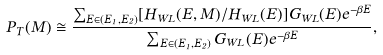<formula> <loc_0><loc_0><loc_500><loc_500>P _ { T } ( M ) \cong \frac { \sum _ { E \in ( E _ { 1 } , E _ { 2 } ) } [ H _ { W L } ( E , M ) / H _ { W L } ( E ) ] G _ { W L } ( E ) e ^ { - \beta E } } { \sum _ { E \in ( E _ { 1 } , E _ { 2 } ) } G _ { W L } ( E ) e ^ { - \beta E } } ,</formula> 